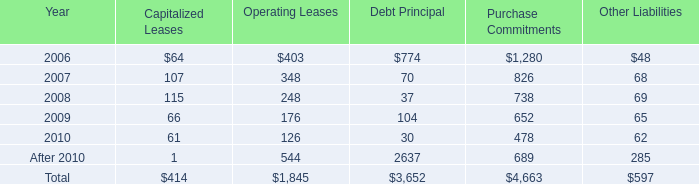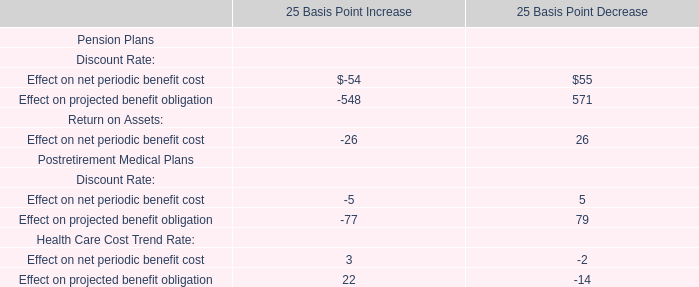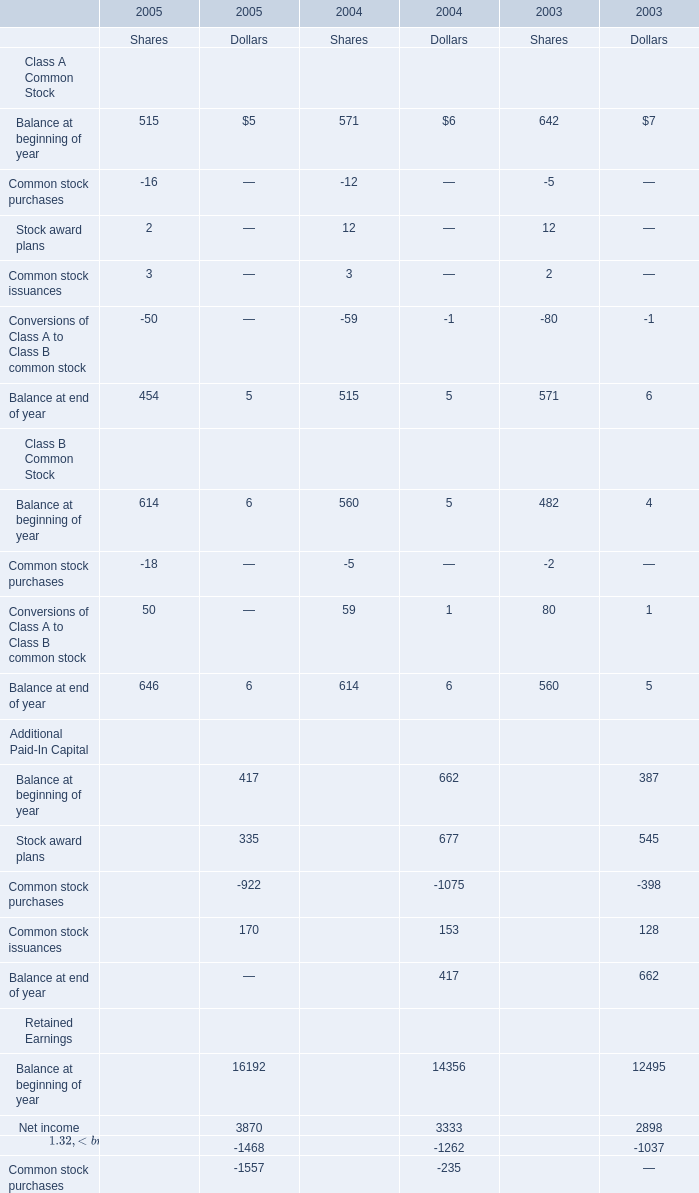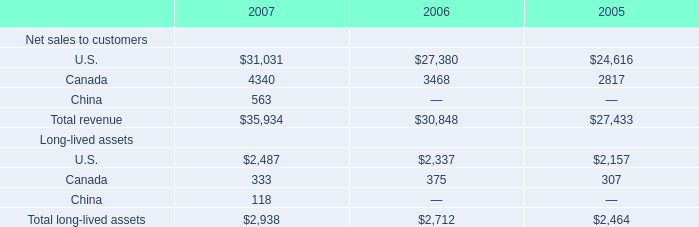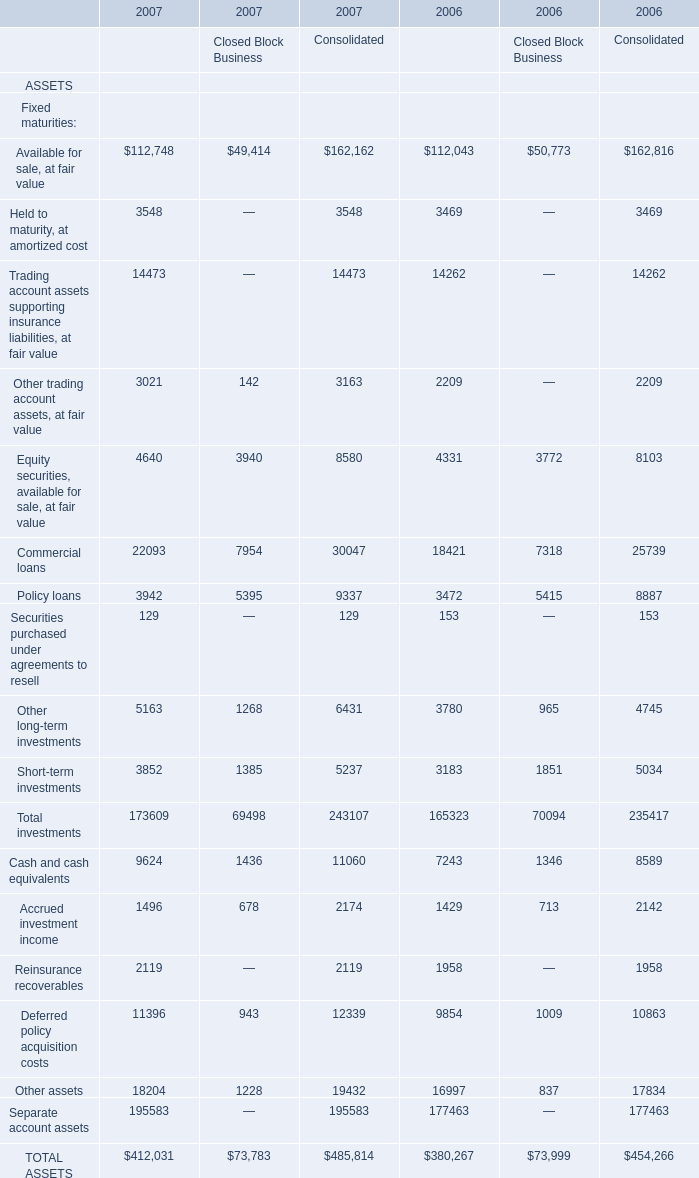What is the sum of Accrued investment income of 2007 Consolidated, Balance at end of year Retained Earnings of 2004 Dollars, and Cash collateral for loaned securities LIABILITIES of 2006 Financial Services Businesses ? 
Computations: ((2174.0 + 16192.0) + 4082.0)
Answer: 22448.0. 